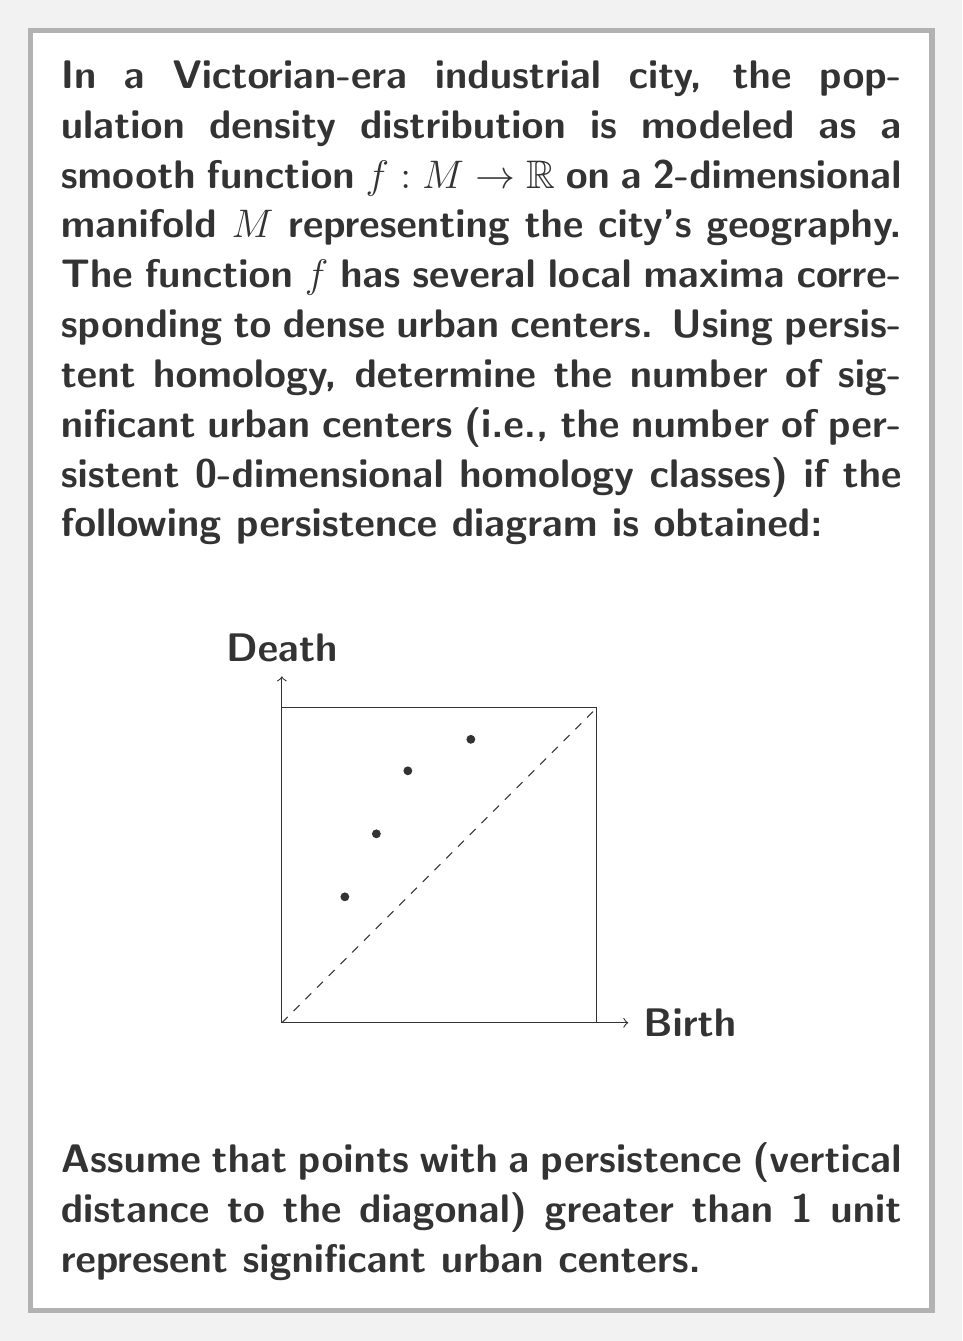Solve this math problem. To solve this problem, we need to understand persistent homology and interpret the given persistence diagram. Let's break it down step-by-step:

1) Persistent homology is a method in topological data analysis that tracks topological features (like connected components) across different scales.

2) In a persistence diagram, each point represents a topological feature. The x-coordinate is the "birth" time, and the y-coordinate is the "death" time of the feature.

3) The persistence of a feature is the difference between its death and birth times, which is visually represented by the vertical distance from the point to the diagonal line.

4) In our context, each point in the diagram represents a potential urban center. The more persistent (longer-living) features are likely to represent more significant urban centers.

5) We're told to consider points with a persistence greater than 1 unit as significant urban centers.

6) Looking at the diagram, we can identify the coordinates of the points approximately as:
   (1, 2), (1.5, 3), (2, 4), (3, 4.5)

7) To calculate the persistence of each point, we subtract its x-coordinate from its y-coordinate:
   (1, 2): 2 - 1 = 1
   (1.5, 3): 3 - 1.5 = 1.5
   (2, 4): 4 - 2 = 2
   (3, 4.5): 4.5 - 3 = 1.5

8) Counting the number of points with persistence greater than 1, we get 3 points:
   (1.5, 3), (2, 4), and (3, 4.5)

Therefore, there are 3 significant urban centers in this Victorian industrial city according to the given persistence diagram and criteria.
Answer: 3 